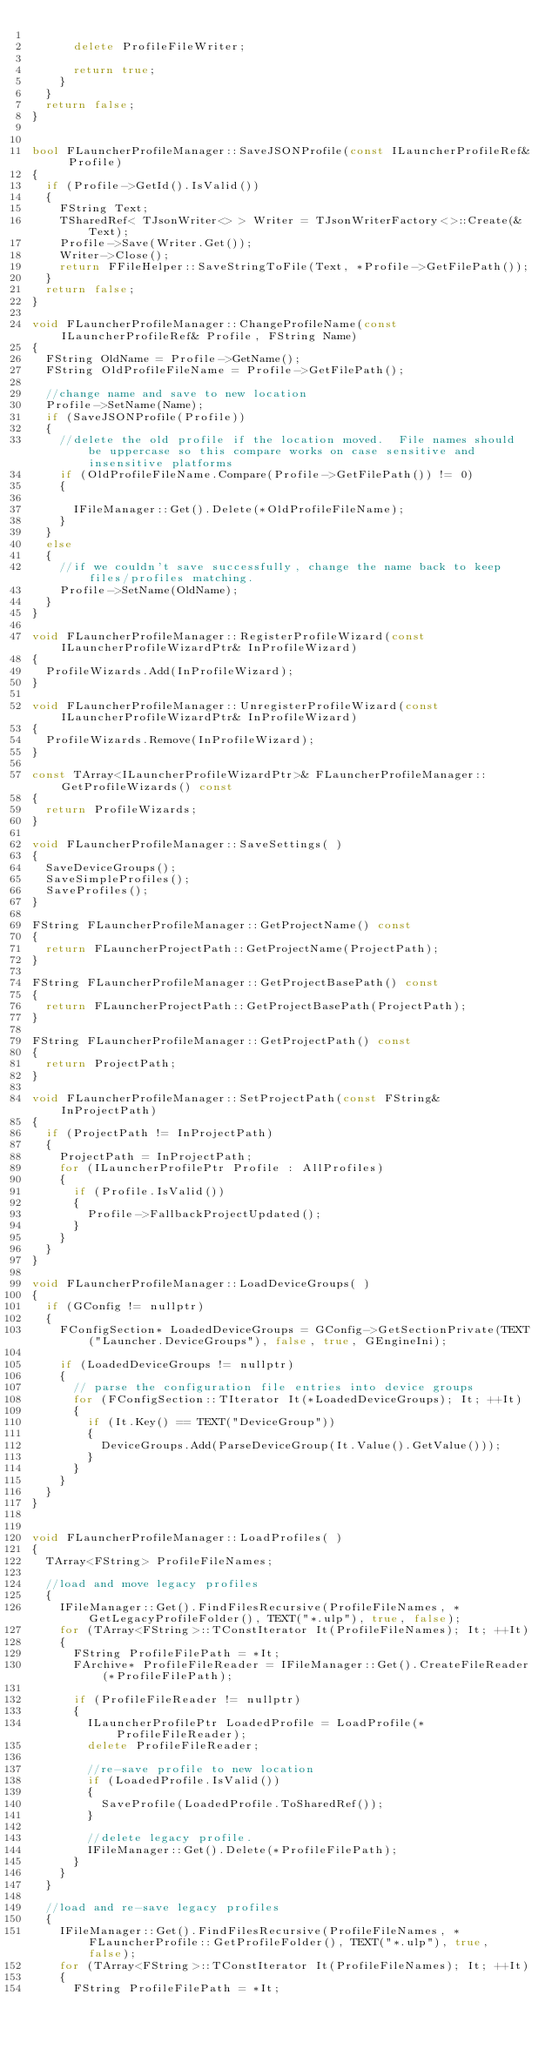Convert code to text. <code><loc_0><loc_0><loc_500><loc_500><_C++_>
			delete ProfileFileWriter;

			return true;
		}
	}
	return false;
}


bool FLauncherProfileManager::SaveJSONProfile(const ILauncherProfileRef& Profile)
{
	if (Profile->GetId().IsValid())
	{
		FString Text;
		TSharedRef< TJsonWriter<> > Writer = TJsonWriterFactory<>::Create(&Text);
		Profile->Save(Writer.Get());
		Writer->Close();
		return FFileHelper::SaveStringToFile(Text, *Profile->GetFilePath());
	}
	return false;
}

void FLauncherProfileManager::ChangeProfileName(const ILauncherProfileRef& Profile, FString Name)
{
	FString OldName = Profile->GetName();
	FString OldProfileFileName = Profile->GetFilePath();

	//change name and save to new location
	Profile->SetName(Name);
	if (SaveJSONProfile(Profile))
	{
		//delete the old profile if the location moved.  File names should be uppercase so this compare works on case sensitive and insensitive platforms
		if (OldProfileFileName.Compare(Profile->GetFilePath()) != 0)
		{
			
			IFileManager::Get().Delete(*OldProfileFileName);
		}
	}
	else
	{
		//if we couldn't save successfully, change the name back to keep files/profiles matching.
		Profile->SetName(OldName);
	}	
}

void FLauncherProfileManager::RegisterProfileWizard(const ILauncherProfileWizardPtr& InProfileWizard)
{
	ProfileWizards.Add(InProfileWizard);
}

void FLauncherProfileManager::UnregisterProfileWizard(const ILauncherProfileWizardPtr& InProfileWizard)
{
	ProfileWizards.Remove(InProfileWizard);
}

const TArray<ILauncherProfileWizardPtr>& FLauncherProfileManager::GetProfileWizards() const
{
	return ProfileWizards;
}

void FLauncherProfileManager::SaveSettings( )
{
	SaveDeviceGroups();
	SaveSimpleProfiles();
	SaveProfiles();
}

FString FLauncherProfileManager::GetProjectName() const
{
	return FLauncherProjectPath::GetProjectName(ProjectPath);
}

FString FLauncherProfileManager::GetProjectBasePath() const
{
	return FLauncherProjectPath::GetProjectBasePath(ProjectPath);
}

FString FLauncherProfileManager::GetProjectPath() const
{
	return ProjectPath;
}

void FLauncherProfileManager::SetProjectPath(const FString& InProjectPath)
{
	if (ProjectPath != InProjectPath)
	{
		ProjectPath = InProjectPath;
		for (ILauncherProfilePtr Profile : AllProfiles)
		{
			if (Profile.IsValid())
			{
				Profile->FallbackProjectUpdated();
			}
		}
	}
}

void FLauncherProfileManager::LoadDeviceGroups( )
{
	if (GConfig != nullptr)
	{
		FConfigSection* LoadedDeviceGroups = GConfig->GetSectionPrivate(TEXT("Launcher.DeviceGroups"), false, true, GEngineIni);

		if (LoadedDeviceGroups != nullptr)
		{
			// parse the configuration file entries into device groups
			for (FConfigSection::TIterator It(*LoadedDeviceGroups); It; ++It)
			{
				if (It.Key() == TEXT("DeviceGroup"))
				{
					DeviceGroups.Add(ParseDeviceGroup(It.Value().GetValue()));
				}
			}
		}
	}
}


void FLauncherProfileManager::LoadProfiles( )
{
	TArray<FString> ProfileFileNames;

	//load and move legacy profiles
	{
		IFileManager::Get().FindFilesRecursive(ProfileFileNames, *GetLegacyProfileFolder(), TEXT("*.ulp"), true, false);
		for (TArray<FString>::TConstIterator It(ProfileFileNames); It; ++It)
		{
			FString ProfileFilePath = *It;
			FArchive* ProfileFileReader = IFileManager::Get().CreateFileReader(*ProfileFilePath);

			if (ProfileFileReader != nullptr)
			{
				ILauncherProfilePtr LoadedProfile = LoadProfile(*ProfileFileReader);
				delete ProfileFileReader;

				//re-save profile to new location
				if (LoadedProfile.IsValid())
				{
					SaveProfile(LoadedProfile.ToSharedRef());
				}

				//delete legacy profile.
				IFileManager::Get().Delete(*ProfileFilePath);				
			}
		}
	}

	//load and re-save legacy profiles
	{
		IFileManager::Get().FindFilesRecursive(ProfileFileNames, *FLauncherProfile::GetProfileFolder(), TEXT("*.ulp"), true, false);
		for (TArray<FString>::TConstIterator It(ProfileFileNames); It; ++It)
		{
			FString ProfileFilePath = *It;</code> 